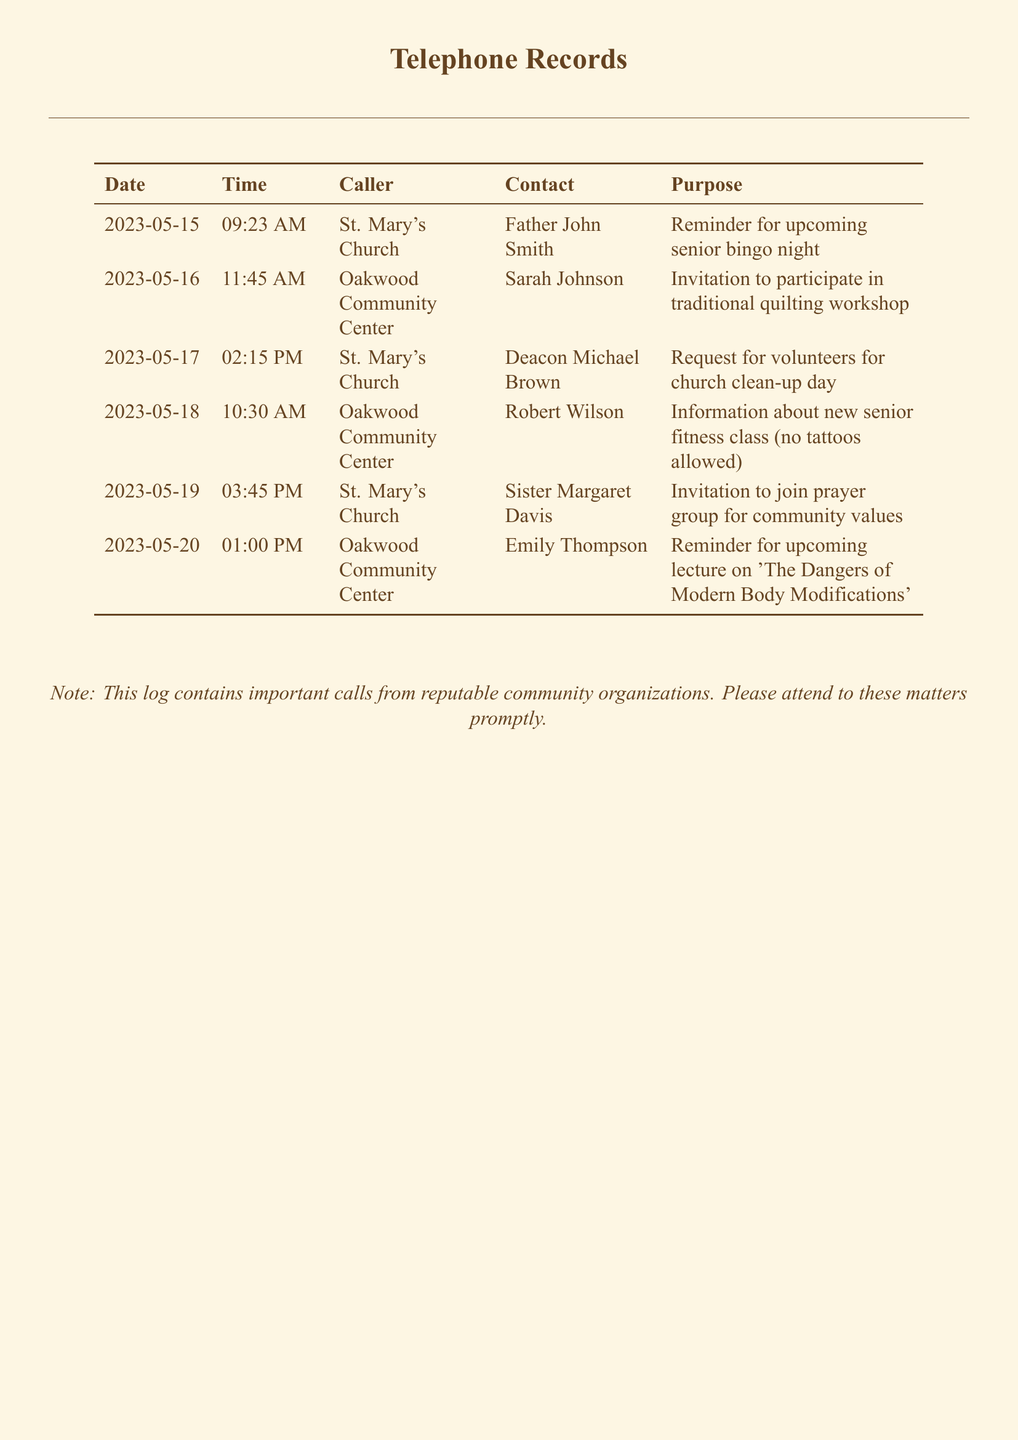what is the date of the first call? The first call in the document is logged on May 15, 2023.
Answer: May 15, 2023 who called at 11:45 AM on May 16? At 11:45 AM on May 16, Oakwood Community Center called Sarah Johnson.
Answer: Sarah Johnson what is the purpose of the call from Sister Margaret Davis? The purpose of Sister Margaret Davis's call is to invite community members to join a prayer group focused on community values.
Answer: Invitation to join prayer group for community values how many calls were made by St. Mary's Church? There are three calls made by St. Mary's Church in the document.
Answer: Three what is the time of the call regarding the traditional quilting workshop? The call regarding the traditional quilting workshop was made at 11:45 AM.
Answer: 11:45 AM which organization provided information about a new fitness class? The organization that provided information about the new fitness class is Oakwood Community Center.
Answer: Oakwood Community Center what is the date of the call that discusses modern body modifications? The call discussing modern body modifications took place on May 20, 2023.
Answer: May 20, 2023 who is the contact person for the church clean-up day? The contact person for the church clean-up day is Deacon Michael Brown.
Answer: Deacon Michael Brown what reminder was given by the local church on May 15? The reminder given by the local church on May 15 was for the upcoming senior bingo night.
Answer: Reminder for upcoming senior bingo night 